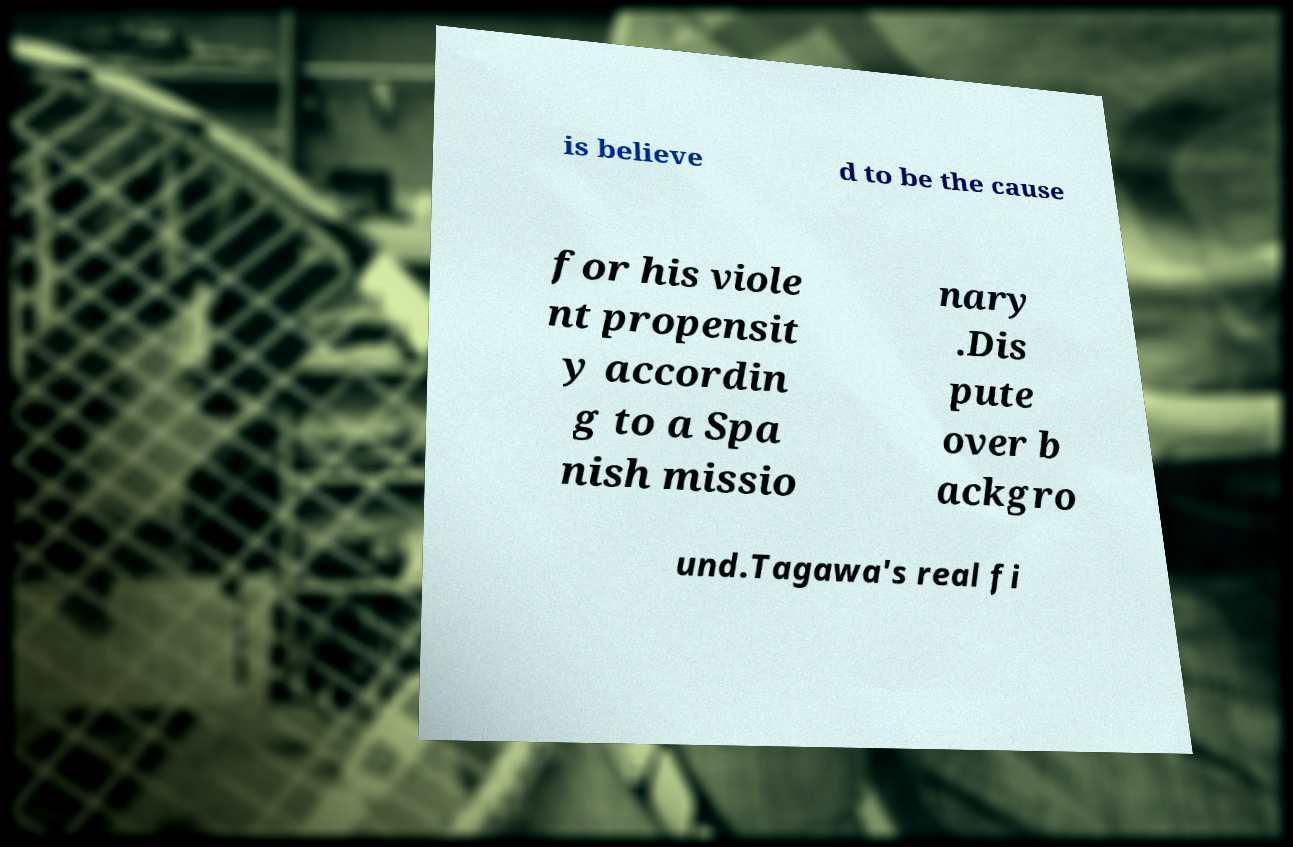What messages or text are displayed in this image? I need them in a readable, typed format. is believe d to be the cause for his viole nt propensit y accordin g to a Spa nish missio nary .Dis pute over b ackgro und.Tagawa's real fi 